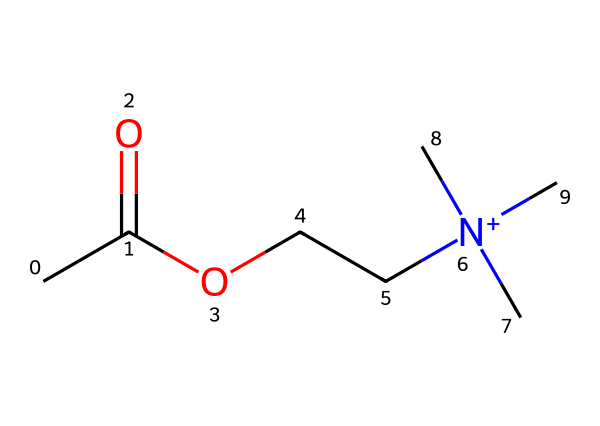What is the functional group present in this chemical? The given SMILES representation contains a carboxylic acid functional group (–COOH) indicated by "CC(=O)O", which shows a carbon double-bonded to an oxygen and single-bonded to a hydroxyl group.
Answer: carboxylic acid How many carbon atoms are in the molecule? Counting the carbon atoms in the SMILES string: "CC(=O)OCC" has a total of four carbon atoms before "N", and considering the nitrogen's three methyl groups, there are three additional carbon atoms. Thus, there are 4 (from the chain) + 3 (from three methyl groups) = 7 carbon atoms.
Answer: 7 What is the total number of nitrogen atoms in the structure? By examining the SMILES representation, we see "[N+](C)(C)C", which indicates there is one nitrogen atom bonded to three methyl groups, confirming the presence of one nitrogen atom in the molecular structure.
Answer: 1 Is the nitrogen in the molecule positively charged? The "[N+]" notation in the SMILES indicates that the nitrogen atom carries a positive charge, making it a quaternary ammonium compound in which nitrogen is bonded to four carbon groups and holds a positive charge.
Answer: yes What type of compound is this molecular structure primarily classified as? Given its structure and presence of functional groups, it is a neurotransmitter-like molecule due to the presence of both the carboxylic acid group and the nitrogen functional group implying its role in communication between nerves.
Answer: neurotransmitter-like 